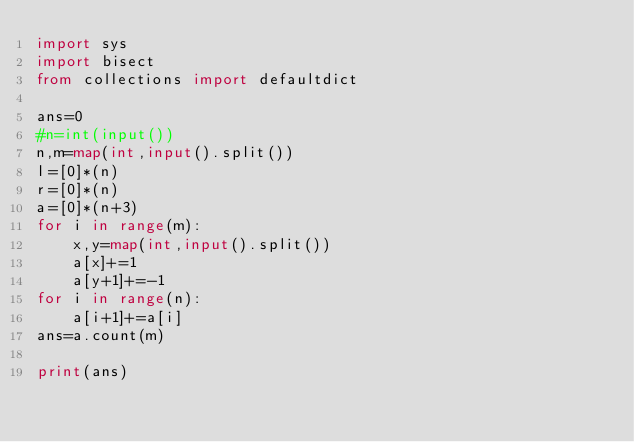Convert code to text. <code><loc_0><loc_0><loc_500><loc_500><_Python_>import sys
import bisect
from collections import defaultdict

ans=0
#n=int(input())
n,m=map(int,input().split())
l=[0]*(n)
r=[0]*(n)
a=[0]*(n+3)
for i in range(m):
    x,y=map(int,input().split())
    a[x]+=1
    a[y+1]+=-1
for i in range(n):
    a[i+1]+=a[i]
ans=a.count(m)

print(ans)</code> 